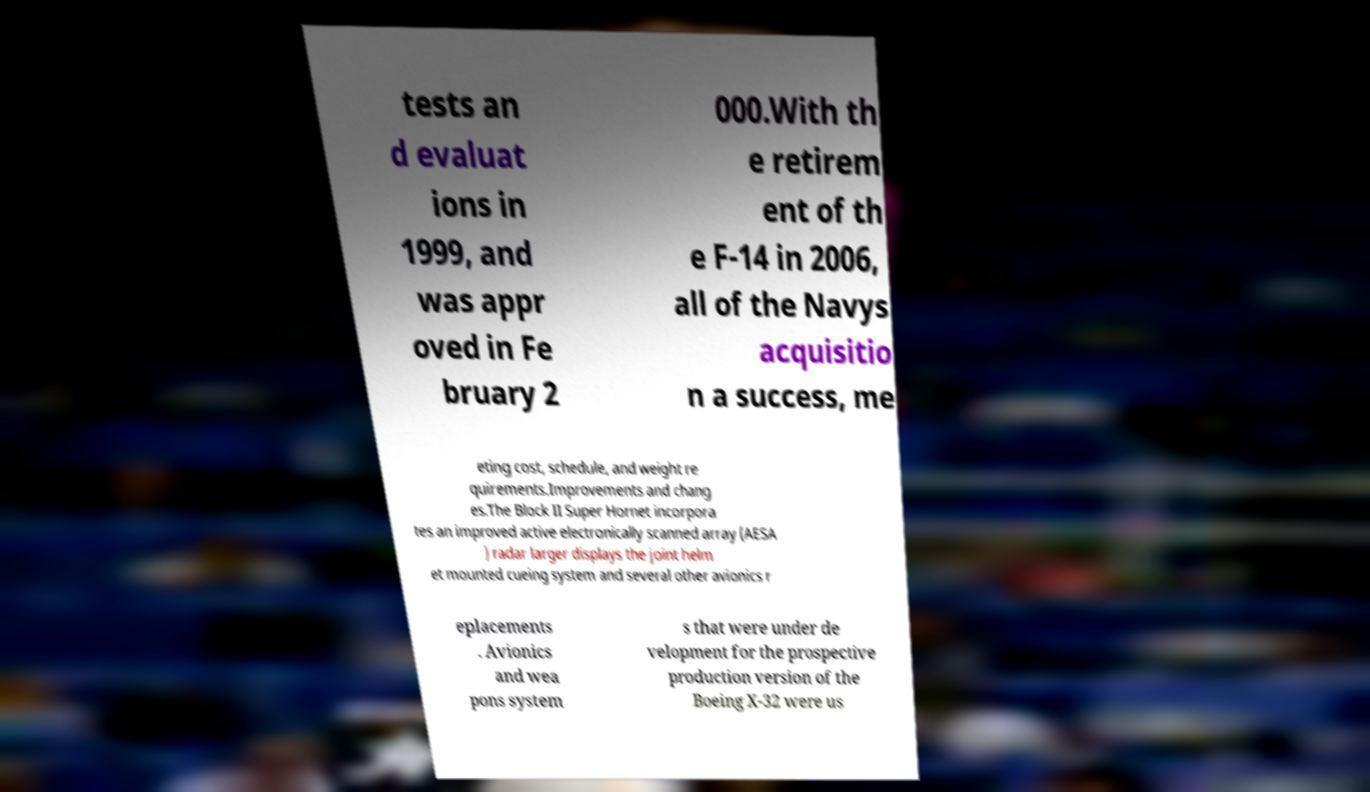There's text embedded in this image that I need extracted. Can you transcribe it verbatim? tests an d evaluat ions in 1999, and was appr oved in Fe bruary 2 000.With th e retirem ent of th e F-14 in 2006, all of the Navys acquisitio n a success, me eting cost, schedule, and weight re quirements.Improvements and chang es.The Block II Super Hornet incorpora tes an improved active electronically scanned array (AESA ) radar larger displays the joint helm et mounted cueing system and several other avionics r eplacements . Avionics and wea pons system s that were under de velopment for the prospective production version of the Boeing X-32 were us 